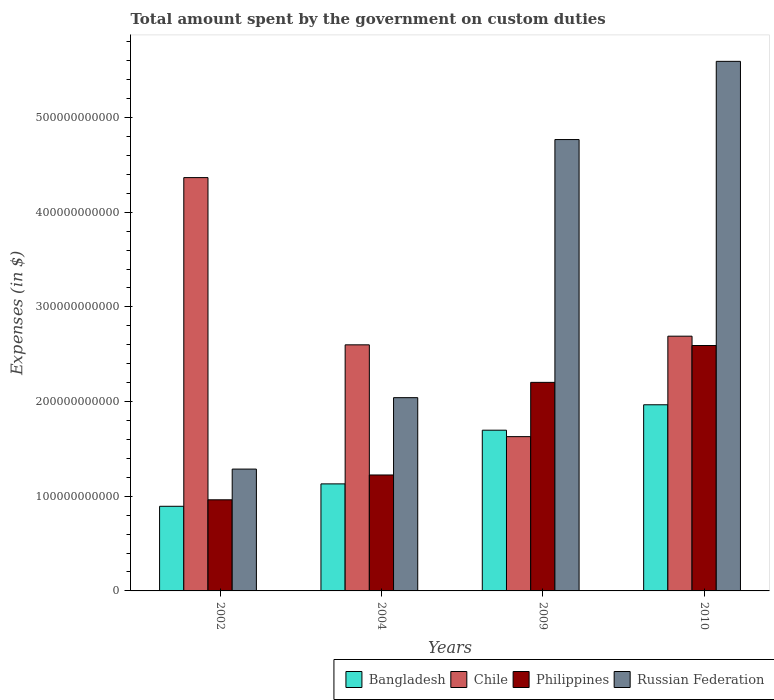Are the number of bars on each tick of the X-axis equal?
Your answer should be compact. Yes. In how many cases, is the number of bars for a given year not equal to the number of legend labels?
Provide a short and direct response. 0. What is the amount spent on custom duties by the government in Philippines in 2009?
Your answer should be very brief. 2.20e+11. Across all years, what is the maximum amount spent on custom duties by the government in Bangladesh?
Give a very brief answer. 1.97e+11. Across all years, what is the minimum amount spent on custom duties by the government in Philippines?
Offer a very short reply. 9.62e+1. In which year was the amount spent on custom duties by the government in Russian Federation minimum?
Your answer should be compact. 2002. What is the total amount spent on custom duties by the government in Philippines in the graph?
Offer a terse response. 6.98e+11. What is the difference between the amount spent on custom duties by the government in Philippines in 2002 and that in 2010?
Keep it short and to the point. -1.63e+11. What is the difference between the amount spent on custom duties by the government in Russian Federation in 2009 and the amount spent on custom duties by the government in Philippines in 2004?
Make the answer very short. 3.54e+11. What is the average amount spent on custom duties by the government in Philippines per year?
Give a very brief answer. 1.75e+11. In the year 2002, what is the difference between the amount spent on custom duties by the government in Philippines and amount spent on custom duties by the government in Bangladesh?
Give a very brief answer. 6.86e+09. In how many years, is the amount spent on custom duties by the government in Philippines greater than 420000000000 $?
Provide a short and direct response. 0. What is the ratio of the amount spent on custom duties by the government in Chile in 2004 to that in 2010?
Your answer should be compact. 0.97. Is the amount spent on custom duties by the government in Philippines in 2004 less than that in 2010?
Offer a terse response. Yes. Is the difference between the amount spent on custom duties by the government in Philippines in 2002 and 2004 greater than the difference between the amount spent on custom duties by the government in Bangladesh in 2002 and 2004?
Your answer should be very brief. No. What is the difference between the highest and the second highest amount spent on custom duties by the government in Russian Federation?
Provide a succinct answer. 8.26e+1. What is the difference between the highest and the lowest amount spent on custom duties by the government in Philippines?
Make the answer very short. 1.63e+11. In how many years, is the amount spent on custom duties by the government in Russian Federation greater than the average amount spent on custom duties by the government in Russian Federation taken over all years?
Provide a succinct answer. 2. How many bars are there?
Your response must be concise. 16. Are all the bars in the graph horizontal?
Make the answer very short. No. How many years are there in the graph?
Provide a short and direct response. 4. What is the difference between two consecutive major ticks on the Y-axis?
Offer a terse response. 1.00e+11. Are the values on the major ticks of Y-axis written in scientific E-notation?
Offer a very short reply. No. How many legend labels are there?
Your response must be concise. 4. How are the legend labels stacked?
Offer a terse response. Horizontal. What is the title of the graph?
Make the answer very short. Total amount spent by the government on custom duties. Does "Iran" appear as one of the legend labels in the graph?
Provide a short and direct response. No. What is the label or title of the X-axis?
Offer a very short reply. Years. What is the label or title of the Y-axis?
Provide a short and direct response. Expenses (in $). What is the Expenses (in $) in Bangladesh in 2002?
Provide a succinct answer. 8.94e+1. What is the Expenses (in $) of Chile in 2002?
Your answer should be compact. 4.37e+11. What is the Expenses (in $) of Philippines in 2002?
Offer a very short reply. 9.62e+1. What is the Expenses (in $) of Russian Federation in 2002?
Offer a terse response. 1.29e+11. What is the Expenses (in $) of Bangladesh in 2004?
Ensure brevity in your answer.  1.13e+11. What is the Expenses (in $) of Chile in 2004?
Give a very brief answer. 2.60e+11. What is the Expenses (in $) of Philippines in 2004?
Provide a short and direct response. 1.22e+11. What is the Expenses (in $) of Russian Federation in 2004?
Ensure brevity in your answer.  2.04e+11. What is the Expenses (in $) in Bangladesh in 2009?
Offer a terse response. 1.70e+11. What is the Expenses (in $) of Chile in 2009?
Make the answer very short. 1.63e+11. What is the Expenses (in $) of Philippines in 2009?
Make the answer very short. 2.20e+11. What is the Expenses (in $) in Russian Federation in 2009?
Your answer should be very brief. 4.77e+11. What is the Expenses (in $) of Bangladesh in 2010?
Offer a terse response. 1.97e+11. What is the Expenses (in $) of Chile in 2010?
Give a very brief answer. 2.69e+11. What is the Expenses (in $) in Philippines in 2010?
Offer a terse response. 2.59e+11. What is the Expenses (in $) of Russian Federation in 2010?
Provide a succinct answer. 5.59e+11. Across all years, what is the maximum Expenses (in $) of Bangladesh?
Your answer should be very brief. 1.97e+11. Across all years, what is the maximum Expenses (in $) of Chile?
Your answer should be very brief. 4.37e+11. Across all years, what is the maximum Expenses (in $) of Philippines?
Provide a short and direct response. 2.59e+11. Across all years, what is the maximum Expenses (in $) of Russian Federation?
Provide a succinct answer. 5.59e+11. Across all years, what is the minimum Expenses (in $) of Bangladesh?
Give a very brief answer. 8.94e+1. Across all years, what is the minimum Expenses (in $) in Chile?
Offer a terse response. 1.63e+11. Across all years, what is the minimum Expenses (in $) of Philippines?
Your answer should be very brief. 9.62e+1. Across all years, what is the minimum Expenses (in $) of Russian Federation?
Offer a terse response. 1.29e+11. What is the total Expenses (in $) of Bangladesh in the graph?
Make the answer very short. 5.69e+11. What is the total Expenses (in $) in Chile in the graph?
Give a very brief answer. 1.13e+12. What is the total Expenses (in $) in Philippines in the graph?
Make the answer very short. 6.98e+11. What is the total Expenses (in $) in Russian Federation in the graph?
Give a very brief answer. 1.37e+12. What is the difference between the Expenses (in $) of Bangladesh in 2002 and that in 2004?
Your answer should be compact. -2.37e+1. What is the difference between the Expenses (in $) in Chile in 2002 and that in 2004?
Provide a short and direct response. 1.77e+11. What is the difference between the Expenses (in $) of Philippines in 2002 and that in 2004?
Your answer should be compact. -2.62e+1. What is the difference between the Expenses (in $) in Russian Federation in 2002 and that in 2004?
Give a very brief answer. -7.55e+1. What is the difference between the Expenses (in $) in Bangladesh in 2002 and that in 2009?
Your answer should be very brief. -8.04e+1. What is the difference between the Expenses (in $) in Chile in 2002 and that in 2009?
Provide a short and direct response. 2.74e+11. What is the difference between the Expenses (in $) in Philippines in 2002 and that in 2009?
Your response must be concise. -1.24e+11. What is the difference between the Expenses (in $) of Russian Federation in 2002 and that in 2009?
Provide a short and direct response. -3.48e+11. What is the difference between the Expenses (in $) in Bangladesh in 2002 and that in 2010?
Your answer should be compact. -1.07e+11. What is the difference between the Expenses (in $) in Chile in 2002 and that in 2010?
Your answer should be very brief. 1.68e+11. What is the difference between the Expenses (in $) in Philippines in 2002 and that in 2010?
Your response must be concise. -1.63e+11. What is the difference between the Expenses (in $) of Russian Federation in 2002 and that in 2010?
Provide a succinct answer. -4.31e+11. What is the difference between the Expenses (in $) of Bangladesh in 2004 and that in 2009?
Provide a succinct answer. -5.67e+1. What is the difference between the Expenses (in $) in Chile in 2004 and that in 2009?
Make the answer very short. 9.70e+1. What is the difference between the Expenses (in $) of Philippines in 2004 and that in 2009?
Your answer should be compact. -9.78e+1. What is the difference between the Expenses (in $) of Russian Federation in 2004 and that in 2009?
Make the answer very short. -2.73e+11. What is the difference between the Expenses (in $) of Bangladesh in 2004 and that in 2010?
Ensure brevity in your answer.  -8.36e+1. What is the difference between the Expenses (in $) in Chile in 2004 and that in 2010?
Keep it short and to the point. -9.14e+09. What is the difference between the Expenses (in $) of Philippines in 2004 and that in 2010?
Make the answer very short. -1.37e+11. What is the difference between the Expenses (in $) of Russian Federation in 2004 and that in 2010?
Provide a succinct answer. -3.55e+11. What is the difference between the Expenses (in $) of Bangladesh in 2009 and that in 2010?
Give a very brief answer. -2.69e+1. What is the difference between the Expenses (in $) of Chile in 2009 and that in 2010?
Your answer should be very brief. -1.06e+11. What is the difference between the Expenses (in $) in Philippines in 2009 and that in 2010?
Offer a terse response. -3.89e+1. What is the difference between the Expenses (in $) in Russian Federation in 2009 and that in 2010?
Offer a very short reply. -8.26e+1. What is the difference between the Expenses (in $) of Bangladesh in 2002 and the Expenses (in $) of Chile in 2004?
Your answer should be very brief. -1.71e+11. What is the difference between the Expenses (in $) of Bangladesh in 2002 and the Expenses (in $) of Philippines in 2004?
Make the answer very short. -3.31e+1. What is the difference between the Expenses (in $) of Bangladesh in 2002 and the Expenses (in $) of Russian Federation in 2004?
Provide a succinct answer. -1.15e+11. What is the difference between the Expenses (in $) in Chile in 2002 and the Expenses (in $) in Philippines in 2004?
Provide a short and direct response. 3.14e+11. What is the difference between the Expenses (in $) in Chile in 2002 and the Expenses (in $) in Russian Federation in 2004?
Give a very brief answer. 2.32e+11. What is the difference between the Expenses (in $) in Philippines in 2002 and the Expenses (in $) in Russian Federation in 2004?
Keep it short and to the point. -1.08e+11. What is the difference between the Expenses (in $) of Bangladesh in 2002 and the Expenses (in $) of Chile in 2009?
Your answer should be very brief. -7.36e+1. What is the difference between the Expenses (in $) of Bangladesh in 2002 and the Expenses (in $) of Philippines in 2009?
Your answer should be very brief. -1.31e+11. What is the difference between the Expenses (in $) of Bangladesh in 2002 and the Expenses (in $) of Russian Federation in 2009?
Your response must be concise. -3.87e+11. What is the difference between the Expenses (in $) of Chile in 2002 and the Expenses (in $) of Philippines in 2009?
Give a very brief answer. 2.16e+11. What is the difference between the Expenses (in $) in Chile in 2002 and the Expenses (in $) in Russian Federation in 2009?
Provide a succinct answer. -4.02e+1. What is the difference between the Expenses (in $) of Philippines in 2002 and the Expenses (in $) of Russian Federation in 2009?
Give a very brief answer. -3.81e+11. What is the difference between the Expenses (in $) in Bangladesh in 2002 and the Expenses (in $) in Chile in 2010?
Your answer should be very brief. -1.80e+11. What is the difference between the Expenses (in $) of Bangladesh in 2002 and the Expenses (in $) of Philippines in 2010?
Your answer should be compact. -1.70e+11. What is the difference between the Expenses (in $) in Bangladesh in 2002 and the Expenses (in $) in Russian Federation in 2010?
Your answer should be compact. -4.70e+11. What is the difference between the Expenses (in $) of Chile in 2002 and the Expenses (in $) of Philippines in 2010?
Offer a very short reply. 1.77e+11. What is the difference between the Expenses (in $) of Chile in 2002 and the Expenses (in $) of Russian Federation in 2010?
Your answer should be very brief. -1.23e+11. What is the difference between the Expenses (in $) in Philippines in 2002 and the Expenses (in $) in Russian Federation in 2010?
Offer a terse response. -4.63e+11. What is the difference between the Expenses (in $) of Bangladesh in 2004 and the Expenses (in $) of Chile in 2009?
Your response must be concise. -4.99e+1. What is the difference between the Expenses (in $) in Bangladesh in 2004 and the Expenses (in $) in Philippines in 2009?
Offer a very short reply. -1.07e+11. What is the difference between the Expenses (in $) of Bangladesh in 2004 and the Expenses (in $) of Russian Federation in 2009?
Offer a very short reply. -3.64e+11. What is the difference between the Expenses (in $) in Chile in 2004 and the Expenses (in $) in Philippines in 2009?
Provide a short and direct response. 3.96e+1. What is the difference between the Expenses (in $) in Chile in 2004 and the Expenses (in $) in Russian Federation in 2009?
Make the answer very short. -2.17e+11. What is the difference between the Expenses (in $) in Philippines in 2004 and the Expenses (in $) in Russian Federation in 2009?
Provide a succinct answer. -3.54e+11. What is the difference between the Expenses (in $) of Bangladesh in 2004 and the Expenses (in $) of Chile in 2010?
Your answer should be compact. -1.56e+11. What is the difference between the Expenses (in $) of Bangladesh in 2004 and the Expenses (in $) of Philippines in 2010?
Your answer should be very brief. -1.46e+11. What is the difference between the Expenses (in $) of Bangladesh in 2004 and the Expenses (in $) of Russian Federation in 2010?
Keep it short and to the point. -4.46e+11. What is the difference between the Expenses (in $) of Chile in 2004 and the Expenses (in $) of Philippines in 2010?
Give a very brief answer. 7.09e+08. What is the difference between the Expenses (in $) of Chile in 2004 and the Expenses (in $) of Russian Federation in 2010?
Your answer should be very brief. -2.99e+11. What is the difference between the Expenses (in $) of Philippines in 2004 and the Expenses (in $) of Russian Federation in 2010?
Keep it short and to the point. -4.37e+11. What is the difference between the Expenses (in $) in Bangladesh in 2009 and the Expenses (in $) in Chile in 2010?
Give a very brief answer. -9.93e+1. What is the difference between the Expenses (in $) in Bangladesh in 2009 and the Expenses (in $) in Philippines in 2010?
Your response must be concise. -8.95e+1. What is the difference between the Expenses (in $) in Bangladesh in 2009 and the Expenses (in $) in Russian Federation in 2010?
Make the answer very short. -3.90e+11. What is the difference between the Expenses (in $) of Chile in 2009 and the Expenses (in $) of Philippines in 2010?
Offer a very short reply. -9.63e+1. What is the difference between the Expenses (in $) of Chile in 2009 and the Expenses (in $) of Russian Federation in 2010?
Your answer should be compact. -3.96e+11. What is the difference between the Expenses (in $) in Philippines in 2009 and the Expenses (in $) in Russian Federation in 2010?
Your answer should be very brief. -3.39e+11. What is the average Expenses (in $) in Bangladesh per year?
Your response must be concise. 1.42e+11. What is the average Expenses (in $) of Chile per year?
Provide a short and direct response. 2.82e+11. What is the average Expenses (in $) in Philippines per year?
Make the answer very short. 1.75e+11. What is the average Expenses (in $) in Russian Federation per year?
Your response must be concise. 3.42e+11. In the year 2002, what is the difference between the Expenses (in $) in Bangladesh and Expenses (in $) in Chile?
Give a very brief answer. -3.47e+11. In the year 2002, what is the difference between the Expenses (in $) in Bangladesh and Expenses (in $) in Philippines?
Offer a very short reply. -6.86e+09. In the year 2002, what is the difference between the Expenses (in $) of Bangladesh and Expenses (in $) of Russian Federation?
Offer a terse response. -3.93e+1. In the year 2002, what is the difference between the Expenses (in $) of Chile and Expenses (in $) of Philippines?
Offer a very short reply. 3.40e+11. In the year 2002, what is the difference between the Expenses (in $) in Chile and Expenses (in $) in Russian Federation?
Ensure brevity in your answer.  3.08e+11. In the year 2002, what is the difference between the Expenses (in $) in Philippines and Expenses (in $) in Russian Federation?
Offer a terse response. -3.24e+1. In the year 2004, what is the difference between the Expenses (in $) of Bangladesh and Expenses (in $) of Chile?
Offer a terse response. -1.47e+11. In the year 2004, what is the difference between the Expenses (in $) of Bangladesh and Expenses (in $) of Philippines?
Your answer should be compact. -9.39e+09. In the year 2004, what is the difference between the Expenses (in $) in Bangladesh and Expenses (in $) in Russian Federation?
Your response must be concise. -9.11e+1. In the year 2004, what is the difference between the Expenses (in $) in Chile and Expenses (in $) in Philippines?
Your answer should be very brief. 1.37e+11. In the year 2004, what is the difference between the Expenses (in $) of Chile and Expenses (in $) of Russian Federation?
Provide a short and direct response. 5.58e+1. In the year 2004, what is the difference between the Expenses (in $) in Philippines and Expenses (in $) in Russian Federation?
Your answer should be compact. -8.17e+1. In the year 2009, what is the difference between the Expenses (in $) in Bangladesh and Expenses (in $) in Chile?
Your answer should be compact. 6.80e+09. In the year 2009, what is the difference between the Expenses (in $) of Bangladesh and Expenses (in $) of Philippines?
Offer a very short reply. -5.05e+1. In the year 2009, what is the difference between the Expenses (in $) in Bangladesh and Expenses (in $) in Russian Federation?
Make the answer very short. -3.07e+11. In the year 2009, what is the difference between the Expenses (in $) of Chile and Expenses (in $) of Philippines?
Offer a terse response. -5.73e+1. In the year 2009, what is the difference between the Expenses (in $) in Chile and Expenses (in $) in Russian Federation?
Your answer should be compact. -3.14e+11. In the year 2009, what is the difference between the Expenses (in $) in Philippines and Expenses (in $) in Russian Federation?
Provide a succinct answer. -2.56e+11. In the year 2010, what is the difference between the Expenses (in $) in Bangladesh and Expenses (in $) in Chile?
Give a very brief answer. -7.24e+1. In the year 2010, what is the difference between the Expenses (in $) in Bangladesh and Expenses (in $) in Philippines?
Provide a succinct answer. -6.26e+1. In the year 2010, what is the difference between the Expenses (in $) of Bangladesh and Expenses (in $) of Russian Federation?
Your response must be concise. -3.63e+11. In the year 2010, what is the difference between the Expenses (in $) in Chile and Expenses (in $) in Philippines?
Your answer should be very brief. 9.85e+09. In the year 2010, what is the difference between the Expenses (in $) of Chile and Expenses (in $) of Russian Federation?
Ensure brevity in your answer.  -2.90e+11. In the year 2010, what is the difference between the Expenses (in $) in Philippines and Expenses (in $) in Russian Federation?
Keep it short and to the point. -3.00e+11. What is the ratio of the Expenses (in $) of Bangladesh in 2002 to that in 2004?
Keep it short and to the point. 0.79. What is the ratio of the Expenses (in $) of Chile in 2002 to that in 2004?
Provide a short and direct response. 1.68. What is the ratio of the Expenses (in $) in Philippines in 2002 to that in 2004?
Make the answer very short. 0.79. What is the ratio of the Expenses (in $) of Russian Federation in 2002 to that in 2004?
Give a very brief answer. 0.63. What is the ratio of the Expenses (in $) in Bangladesh in 2002 to that in 2009?
Offer a terse response. 0.53. What is the ratio of the Expenses (in $) of Chile in 2002 to that in 2009?
Provide a succinct answer. 2.68. What is the ratio of the Expenses (in $) of Philippines in 2002 to that in 2009?
Your answer should be very brief. 0.44. What is the ratio of the Expenses (in $) of Russian Federation in 2002 to that in 2009?
Offer a very short reply. 0.27. What is the ratio of the Expenses (in $) in Bangladesh in 2002 to that in 2010?
Your response must be concise. 0.45. What is the ratio of the Expenses (in $) of Chile in 2002 to that in 2010?
Offer a very short reply. 1.62. What is the ratio of the Expenses (in $) of Philippines in 2002 to that in 2010?
Your answer should be very brief. 0.37. What is the ratio of the Expenses (in $) in Russian Federation in 2002 to that in 2010?
Ensure brevity in your answer.  0.23. What is the ratio of the Expenses (in $) in Bangladesh in 2004 to that in 2009?
Keep it short and to the point. 0.67. What is the ratio of the Expenses (in $) in Chile in 2004 to that in 2009?
Provide a short and direct response. 1.59. What is the ratio of the Expenses (in $) in Philippines in 2004 to that in 2009?
Provide a succinct answer. 0.56. What is the ratio of the Expenses (in $) in Russian Federation in 2004 to that in 2009?
Provide a short and direct response. 0.43. What is the ratio of the Expenses (in $) of Bangladesh in 2004 to that in 2010?
Provide a short and direct response. 0.57. What is the ratio of the Expenses (in $) in Chile in 2004 to that in 2010?
Your response must be concise. 0.97. What is the ratio of the Expenses (in $) in Philippines in 2004 to that in 2010?
Your answer should be very brief. 0.47. What is the ratio of the Expenses (in $) of Russian Federation in 2004 to that in 2010?
Your answer should be compact. 0.36. What is the ratio of the Expenses (in $) of Bangladesh in 2009 to that in 2010?
Keep it short and to the point. 0.86. What is the ratio of the Expenses (in $) in Chile in 2009 to that in 2010?
Your response must be concise. 0.61. What is the ratio of the Expenses (in $) in Philippines in 2009 to that in 2010?
Your response must be concise. 0.85. What is the ratio of the Expenses (in $) of Russian Federation in 2009 to that in 2010?
Offer a very short reply. 0.85. What is the difference between the highest and the second highest Expenses (in $) of Bangladesh?
Provide a short and direct response. 2.69e+1. What is the difference between the highest and the second highest Expenses (in $) of Chile?
Make the answer very short. 1.68e+11. What is the difference between the highest and the second highest Expenses (in $) in Philippines?
Your response must be concise. 3.89e+1. What is the difference between the highest and the second highest Expenses (in $) in Russian Federation?
Make the answer very short. 8.26e+1. What is the difference between the highest and the lowest Expenses (in $) of Bangladesh?
Your answer should be very brief. 1.07e+11. What is the difference between the highest and the lowest Expenses (in $) in Chile?
Offer a very short reply. 2.74e+11. What is the difference between the highest and the lowest Expenses (in $) in Philippines?
Offer a very short reply. 1.63e+11. What is the difference between the highest and the lowest Expenses (in $) of Russian Federation?
Give a very brief answer. 4.31e+11. 